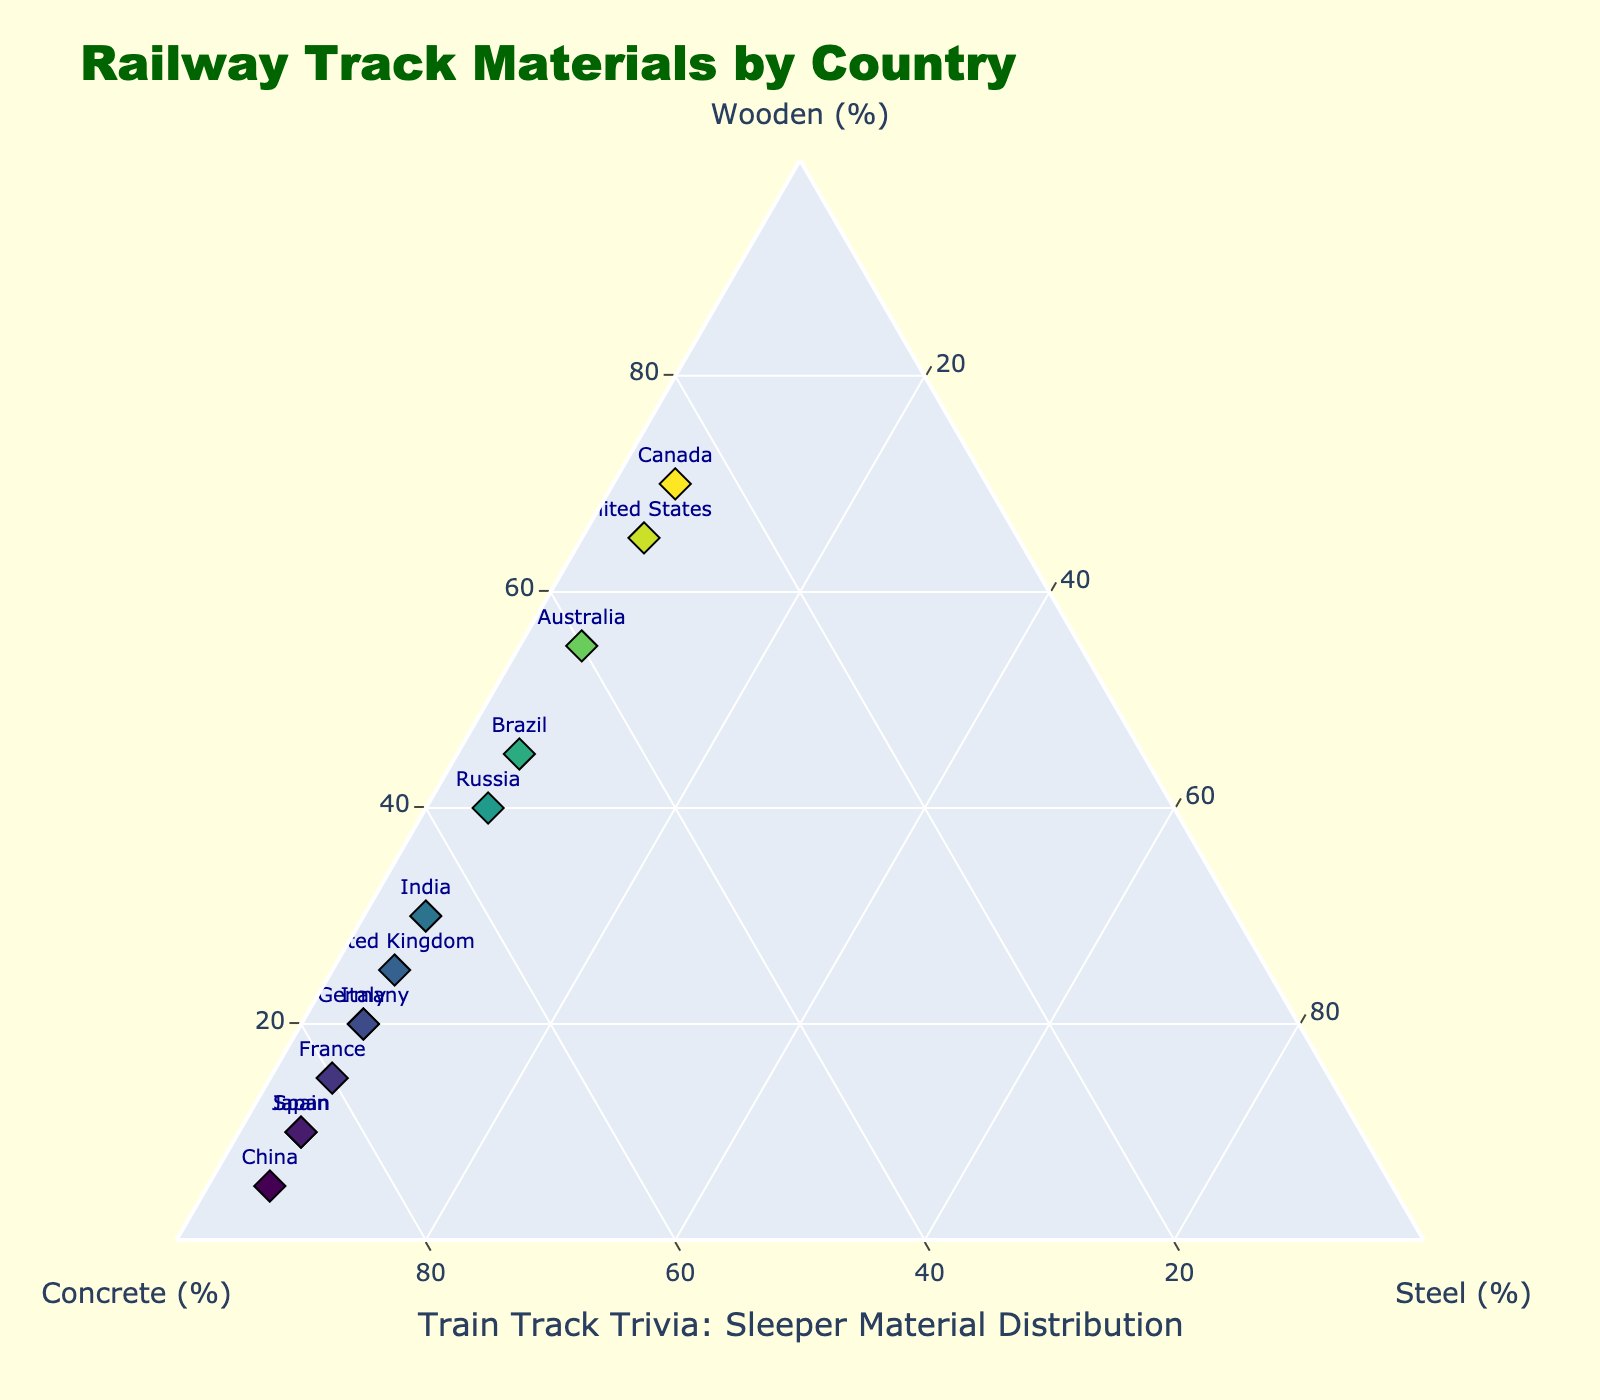What's the title of the figure? The title is displayed prominently at the top of the figure. It's designed to summarize what the plot is about.
Answer: Railway Track Materials by Country How many countries are represented in the ternary plot? By counting the unique labels (country names) in the figure, you can determine the number of countries represented.
Answer: 13 Which country uses the highest percentage of concrete sleepers? Look for the point that is closest to the axis labeled "Concrete (%)" or has the highest value on that axis.
Answer: China What is the percentage of wooden sleepers used in the United States? Locate the point labeled "United States" and note its position relative to the "Wooden (%)" axis.
Answer: 65% Which country has the closest balance between wooden and concrete sleepers, discounting the steel percentage? Find points that lie near the middle or equidistant between the "Wooden (%)" and "Concrete (%)" axes.
Answer: Brazil How does Japan compare to Germany in terms of concrete sleeper usage? Compare the positions of Japan and Germany along the "Concrete (%)" axis. Look at who has the higher value.
Answer: Japan uses more What is the sum of the wooden and concrete sleeper percentages in India? Locate the point for India and sum the values for wooden and concrete sleeper percentages.
Answer: 95% Which country has the least diversity (most skewed) in the types of sleeper materials used? Look for the point furthest along any one of the axes, indicating a heavy reliance on one type of sleeper.
Answer: China Are there any countries that use the same percentage of steel sleepers? Check the value for steel sleepers on each country and see if any have identical percentages.
Answer: Yes, all countries use 5% Which country is closest to having equal percentages of all three types of sleepers? Identify points that are most centrally located, equidistant from all three axes.
Answer: Brazil 